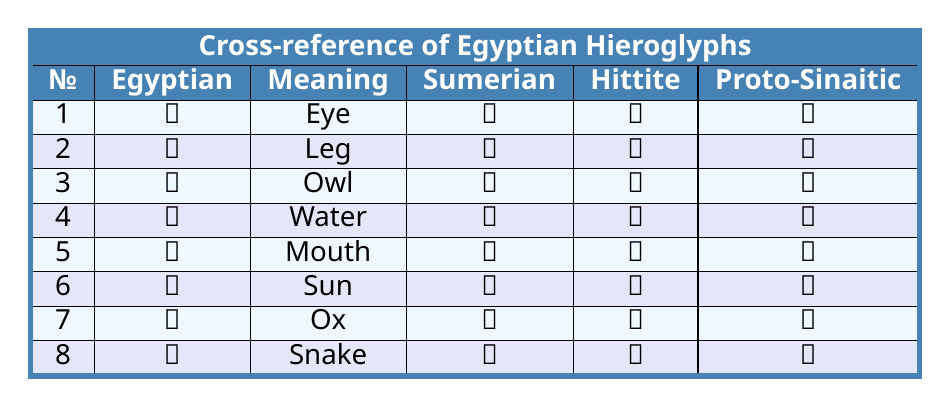What does the Egyptian glyph "𓂀" represent? The glyph "𓂀" corresponds to the meaning "Eye" as indicated in the table.
Answer: Eye Which ancient writing system uses the symbol "𒉺" for the same meaning as the Egyptian glyph "𓂀"? The Sumerian cuneiform symbol "𒉺" has the same meaning as the Egyptian glyph "𓂀" (Eye).
Answer: Sumerian cuneiform Is the Hittite hieroglyph for "Snake" the same as the Proto-Sinaitic symbol? The Hittite hieroglyph for "Snake" is "𔗢" while the Proto-Sinaitic symbol is "𐤍", indicating they are different.
Answer: No What is the meaning of the Egyptian hieroglyph "𓃭"? The hieroglyph "𓃭" means "Ox" according to the table.
Answer: Ox How many different ancient writing systems are compared in this table? The table compares Egyptian hieroglyphs with counterparts in three ancient writing systems: Sumerian cuneiform, Hittite hieroglyphs, and Proto-Sinaitic.
Answer: Three Which symbols represent the same meaning across at least two ancient writing systems? The meaning “Leg” is represented by "𓃀" in Egyptian hieroglyphs, "𒃻" in Sumerian cuneiform, and "𔗷" in Hittite hieroglyphs. The meaning "Water" is represented by "𓈖" in Egyptian hieroglyphs and "𐤌" in Proto-Sinaitic, where "𔗳" is Hittite.
Answer: "Leg" and "Water" What is the Proto-Sinaitic symbol for "Sun"? According to the table, the Proto-Sinaitic symbol for "Sun" is "𐤔".
Answer: 𐤔 Identify the Egyptian glyph that corresponds with the Sumerian cuneiform "𒈲". The Sumerian cuneiform "𒈲" corresponds to the Egyptian glyph "𓆓", which means "Snake".
Answer: 𓆓 Which of the Egyptian hieroglyphs corresponds with the Hittite symbol "𔘳"? The Hittite symbol "𔘳" corresponds with the Egyptian hieroglyph "𓃭" which means "Ox".
Answer: 𓃭 If you combine the meanings of Egyptian glyphs "𓂀" (Eye) and "𓃀" (Leg), what are the total meanings? The combined meanings of the Egyptian glyphs "𓂀" (Eye) and "𓃀" (Leg) is "Eye and Leg". This reflects their respective definitions without mathematical operations.
Answer: Eye and Leg 